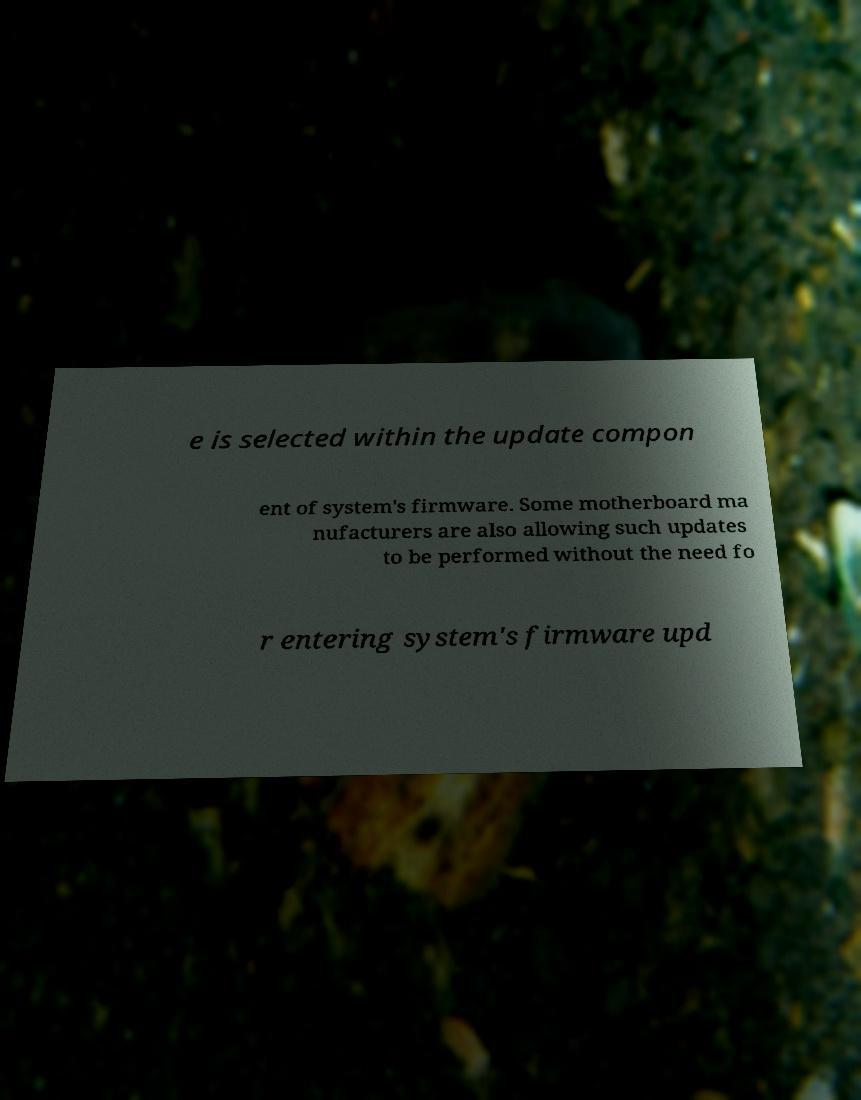Could you assist in decoding the text presented in this image and type it out clearly? e is selected within the update compon ent of system's firmware. Some motherboard ma nufacturers are also allowing such updates to be performed without the need fo r entering system's firmware upd 